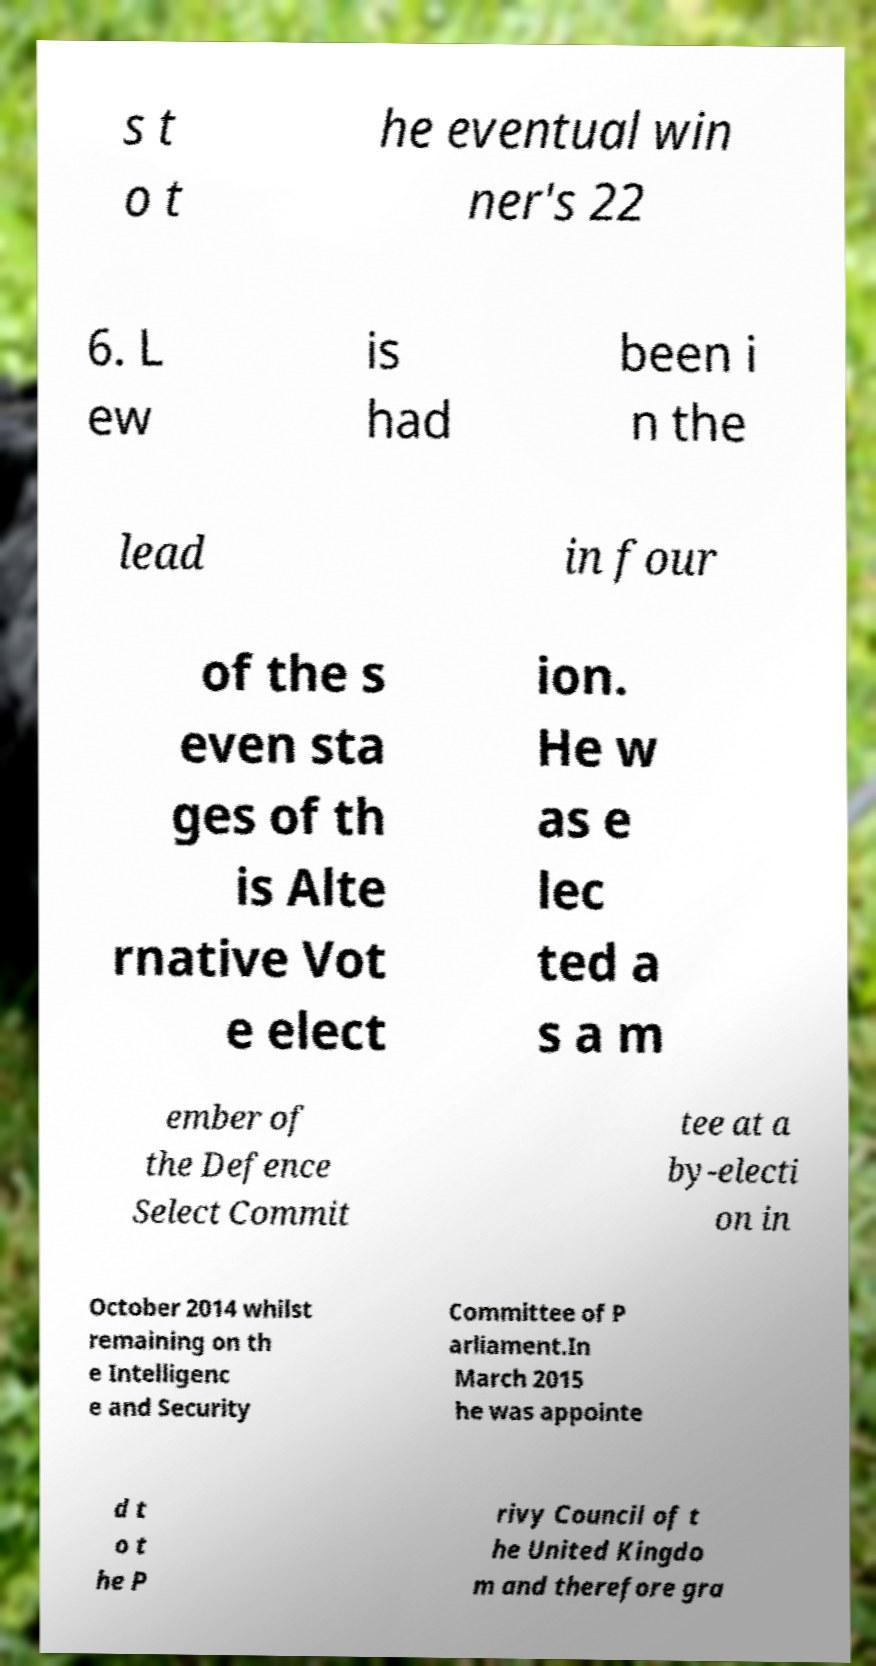For documentation purposes, I need the text within this image transcribed. Could you provide that? s t o t he eventual win ner's 22 6. L ew is had been i n the lead in four of the s even sta ges of th is Alte rnative Vot e elect ion. He w as e lec ted a s a m ember of the Defence Select Commit tee at a by-electi on in October 2014 whilst remaining on th e Intelligenc e and Security Committee of P arliament.In March 2015 he was appointe d t o t he P rivy Council of t he United Kingdo m and therefore gra 